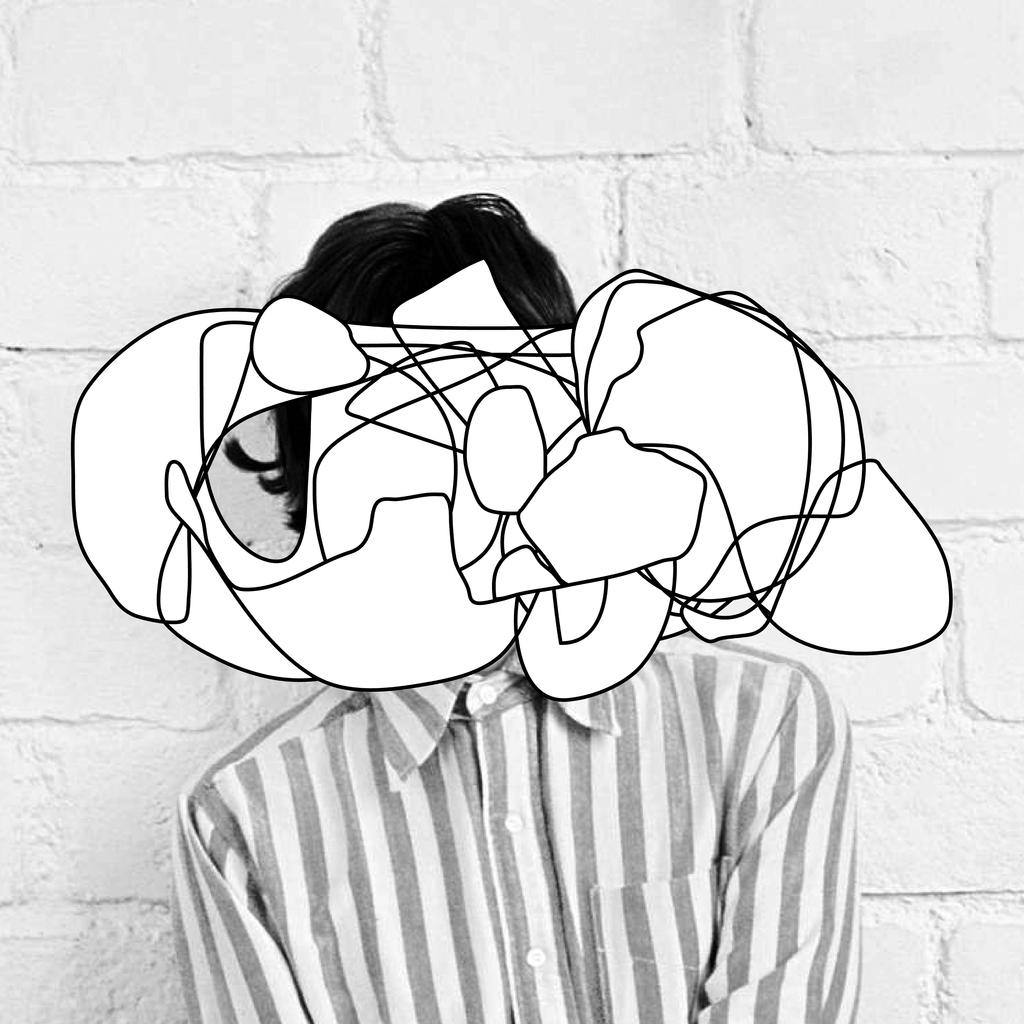What type of image is being described? The image is animated. What is on the person's face in the image? There is a sketch on the person's face. What can be seen in the background of the image? There is a wall in the background of the image. What flavor of hair gel is the person using in the image? There is no mention of hair or hair gel in the image, so it cannot be determined what flavor might be used. 